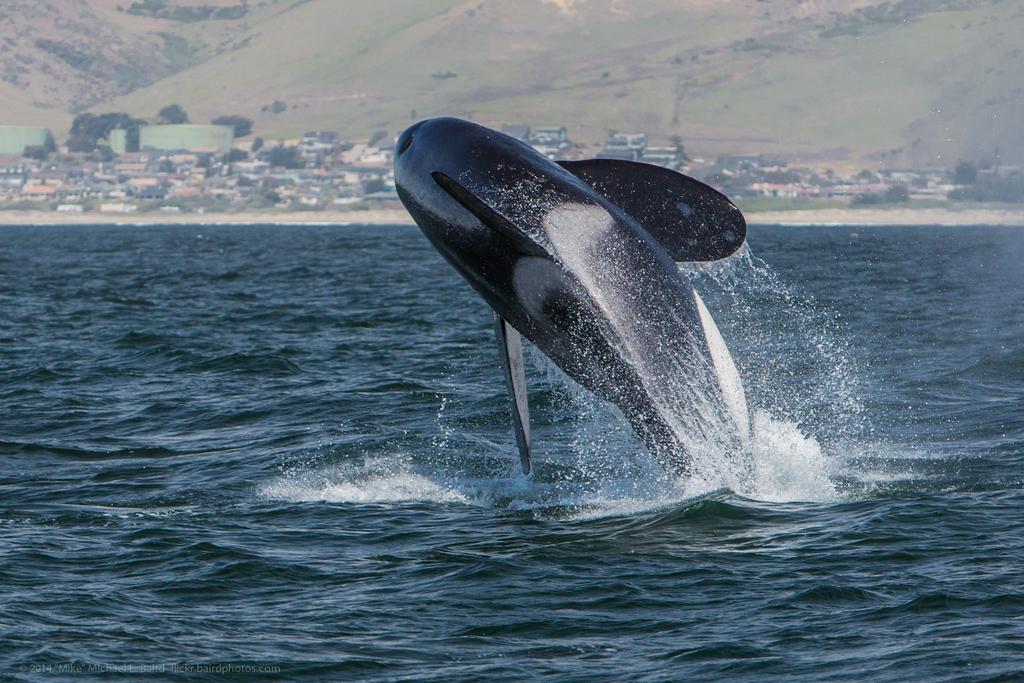How would you summarize this image in a sentence or two? This image consists of water. There is dolphin in the middle. There are houses and trees in the middle. There is something like mountain at the top. 